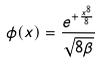Convert formula to latex. <formula><loc_0><loc_0><loc_500><loc_500>\phi ( x ) = \frac { e ^ { + \frac { x ^ { 8 } } { 8 } } } { \sqrt { 8 \beta } }</formula> 